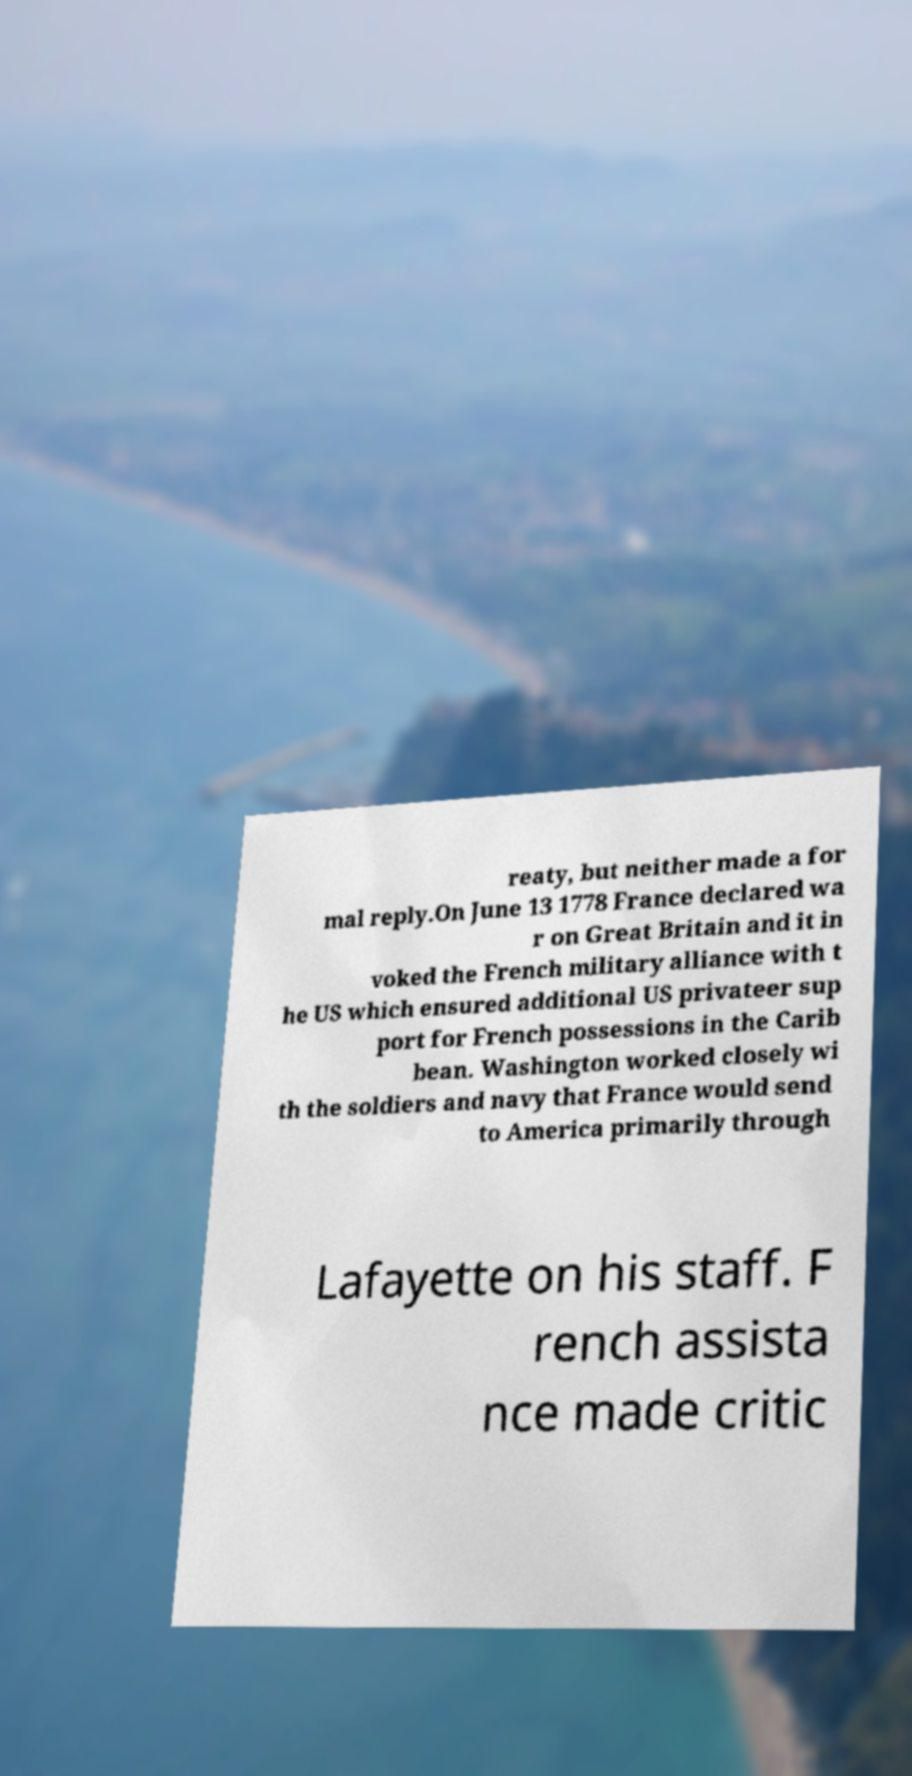Can you read and provide the text displayed in the image?This photo seems to have some interesting text. Can you extract and type it out for me? reaty, but neither made a for mal reply.On June 13 1778 France declared wa r on Great Britain and it in voked the French military alliance with t he US which ensured additional US privateer sup port for French possessions in the Carib bean. Washington worked closely wi th the soldiers and navy that France would send to America primarily through Lafayette on his staff. F rench assista nce made critic 